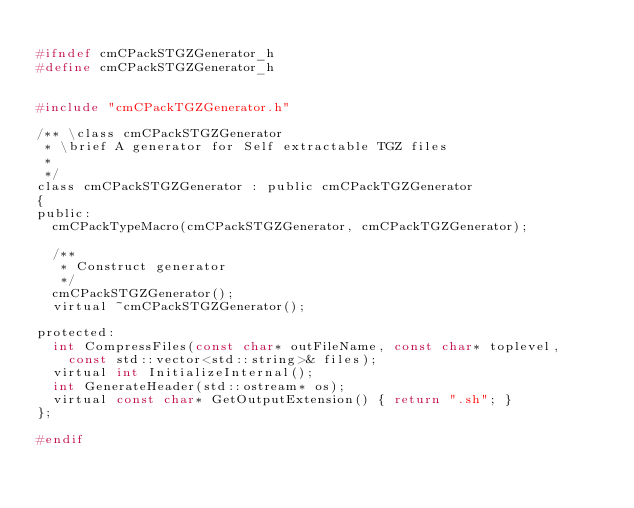<code> <loc_0><loc_0><loc_500><loc_500><_C_>
#ifndef cmCPackSTGZGenerator_h
#define cmCPackSTGZGenerator_h


#include "cmCPackTGZGenerator.h"

/** \class cmCPackSTGZGenerator
 * \brief A generator for Self extractable TGZ files
 *
 */
class cmCPackSTGZGenerator : public cmCPackTGZGenerator
{
public:
  cmCPackTypeMacro(cmCPackSTGZGenerator, cmCPackTGZGenerator);

  /**
   * Construct generator
   */
  cmCPackSTGZGenerator();
  virtual ~cmCPackSTGZGenerator();

protected:
  int CompressFiles(const char* outFileName, const char* toplevel,
    const std::vector<std::string>& files);
  virtual int InitializeInternal();
  int GenerateHeader(std::ostream* os);
  virtual const char* GetOutputExtension() { return ".sh"; }
};

#endif
</code> 